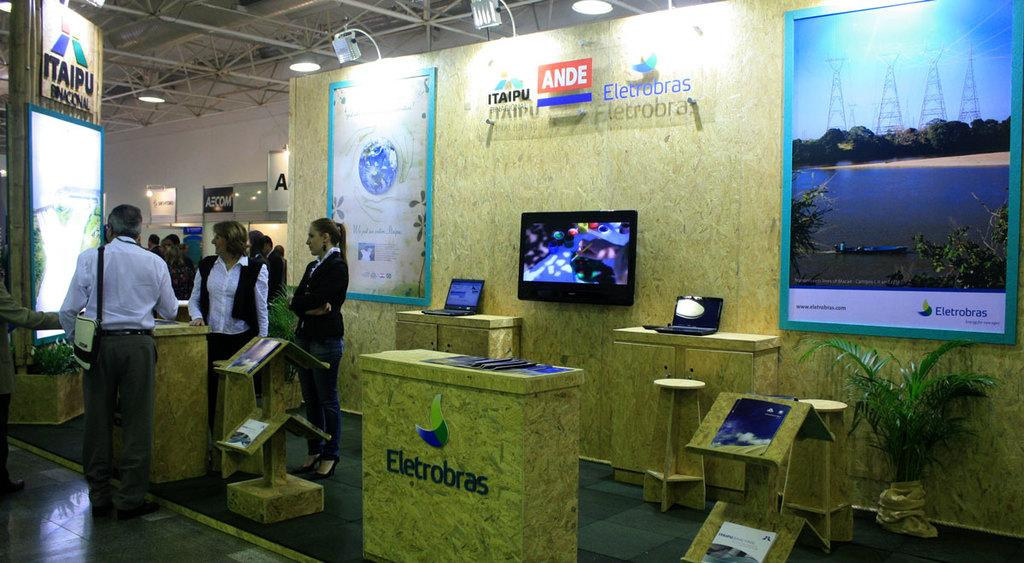Provide a one-sentence caption for the provided image. A convention type setting with representatives from Ande Eletrobras. 